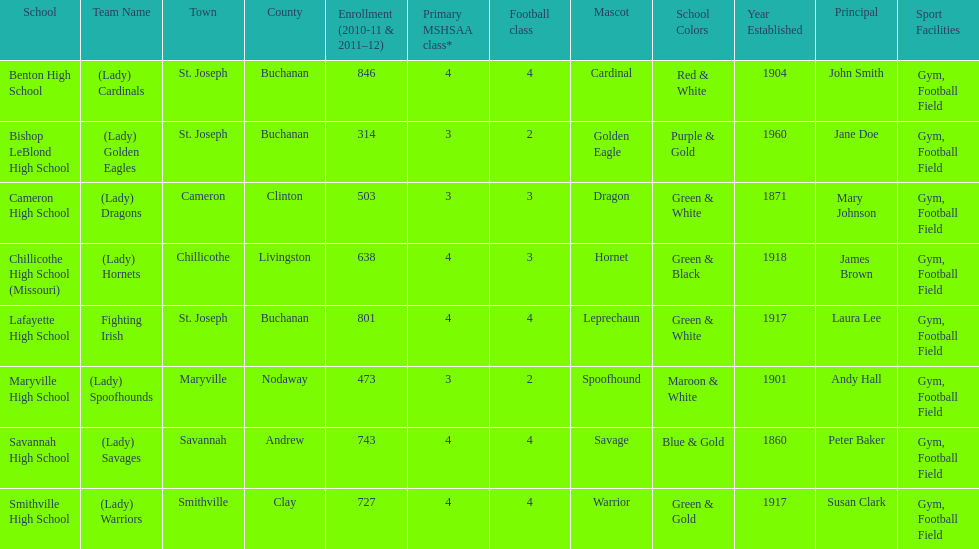How many of the schools had at least 500 students enrolled in the 2010-2011 and 2011-2012 season? 6. 